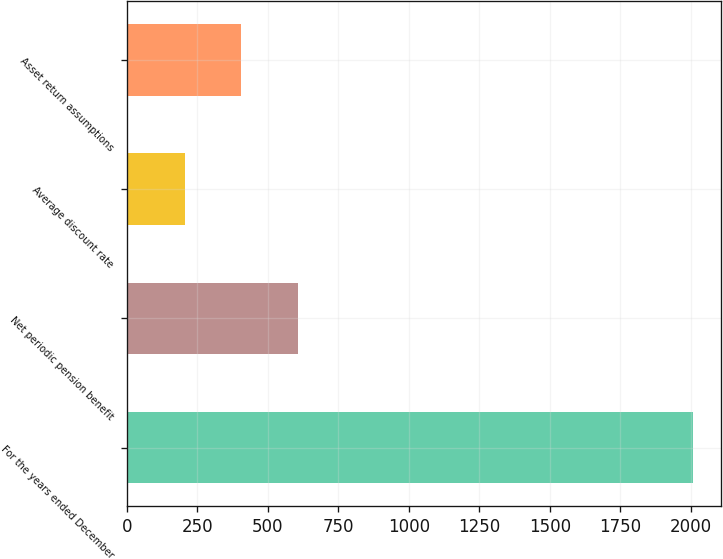Convert chart to OTSL. <chart><loc_0><loc_0><loc_500><loc_500><bar_chart><fcel>For the years ended December<fcel>Net periodic pension benefit<fcel>Average discount rate<fcel>Asset return assumptions<nl><fcel>2007<fcel>606.16<fcel>205.92<fcel>406.04<nl></chart> 